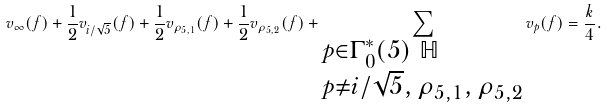<formula> <loc_0><loc_0><loc_500><loc_500>v _ { \infty } ( f ) + \frac { 1 } { 2 } v _ { i / \sqrt { 5 } } ( f ) + \frac { 1 } { 2 } v _ { \rho _ { 5 , 1 } } ( f ) + \frac { 1 } { 2 } v _ { \rho _ { 5 , 2 } } ( f ) + \sum _ { \begin{subarray} { c } p \in \Gamma _ { 0 } ^ { * } ( 5 ) \ \mathbb { H } \\ p \ne i / \sqrt { 5 } , \, \rho _ { 5 , 1 } , \, \rho _ { 5 , 2 } \end{subarray} } v _ { p } ( f ) = \frac { k } { 4 } .</formula> 